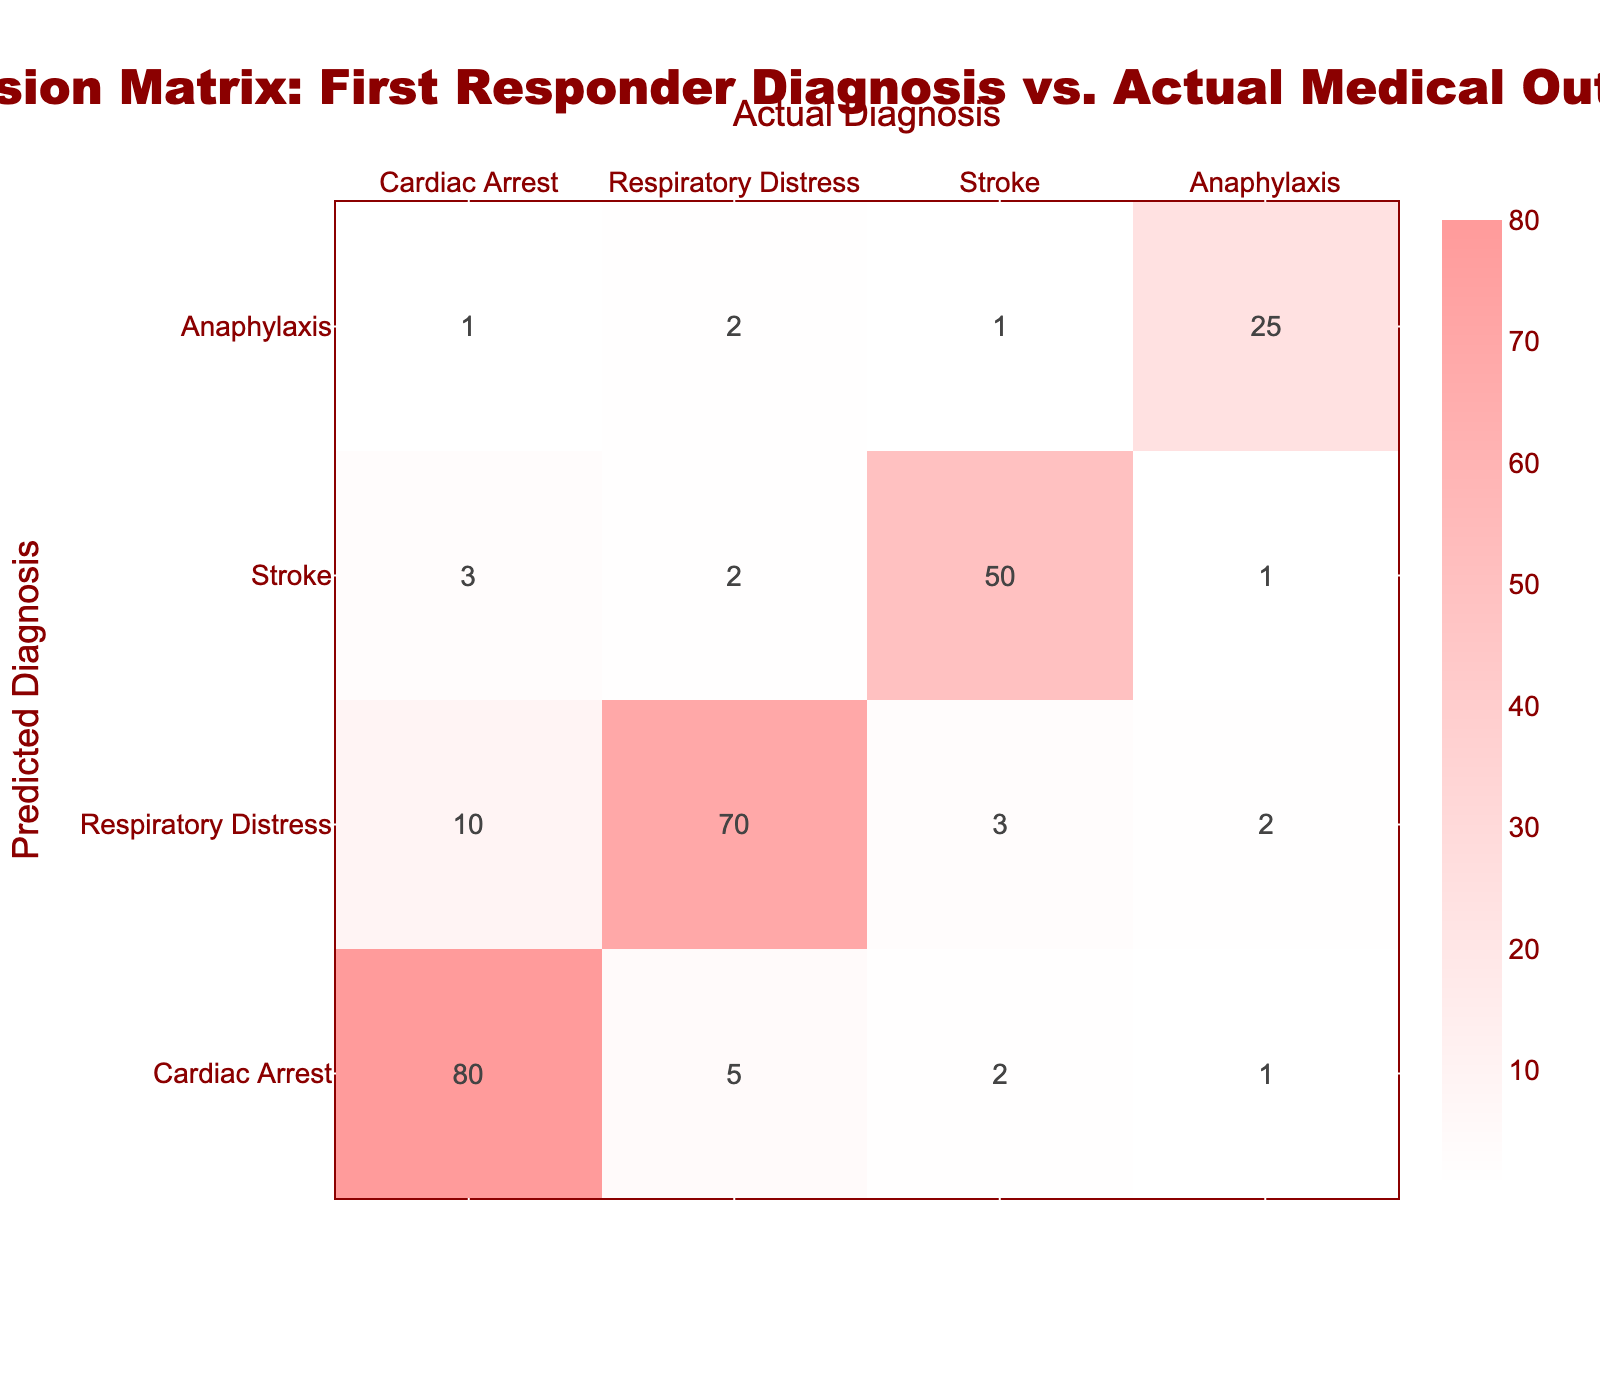What is the total count of cases diagnosed as Cardiac Arrest? To find the total count for Cardiac Arrest, I look at the row for "Cardiac Arrest" in the Predicted Diagnosis section. The counts for true diagnoses under this prediction are: Cardiac Arrest (80), Respiratory Distress (5), Stroke (2), and Anaphylaxis (1). Adding them up gives: 80 + 5 + 2 + 1 = 88.
Answer: 88 What percentage of actual Stroke cases were correctly predicted as Stroke? To find this percentage, I need to look at the row for "Stroke" under Predicted Diagnosis. The count for cases predicted as Stroke that were indeed Stroke is 50. The total actual Stroke cases, calculated from the Stroke row, is the sum of 3 (Cardiac Arrest), 2 (Respiratory Distress), 50 (Stroke), and 1 (Anaphylaxis), which equals 56. The percentage is then (50/56) * 100 = 89.3%.
Answer: 89.3% How many cases were incorrectly diagnosed as Respiratory Distress? To determine the incorrectly diagnosed cases, I refer to the row for "Respiratory Distress." The counts here show 10 cases correctly identified as Cardiac Arrest (incorrect) and 3 cases for Stroke (also incorrect) along with 2 for Anaphylaxis (incorrect). Adding these up gives: 10 + 3 + 2 = 15.
Answer: 15 Are there more cases of true Anaphylaxis diagnosed correctly than incorrectly? I check the counts for Anaphylaxis in the predicted row. The count for Anaphylaxis correctly diagnosed is 25. The incorrectly diagnosed counts would be 1 (Cardiac Arrest) + 2 (Respiratory Distress) + 1 (Stroke) = 4. Since 25 > 4, the answer is Yes.
Answer: Yes What is the overall accuracy of the first responder diagnoses? The overall accuracy can be calculated by dividing the sum of the correctly predicted cases by the total cases. The sum of correct predictions is 80 (Cardiac Arrest) + 70 (Respiratory Distress) + 50 (Stroke) + 25 (Anaphylaxis) = 225. The total count of cases summed overall is 88. Thus, the overall accuracy is (225 / 313) * 100, which requires calculating the total number of predictions (225 + 5 + 2 + 1 + 10 + 3 + 2 + 2 + 3 + 2 + 50 + 1 + 1 + 2 + 1) = 313. The accuracy is approximately 71.8%.
Answer: 71.8% 